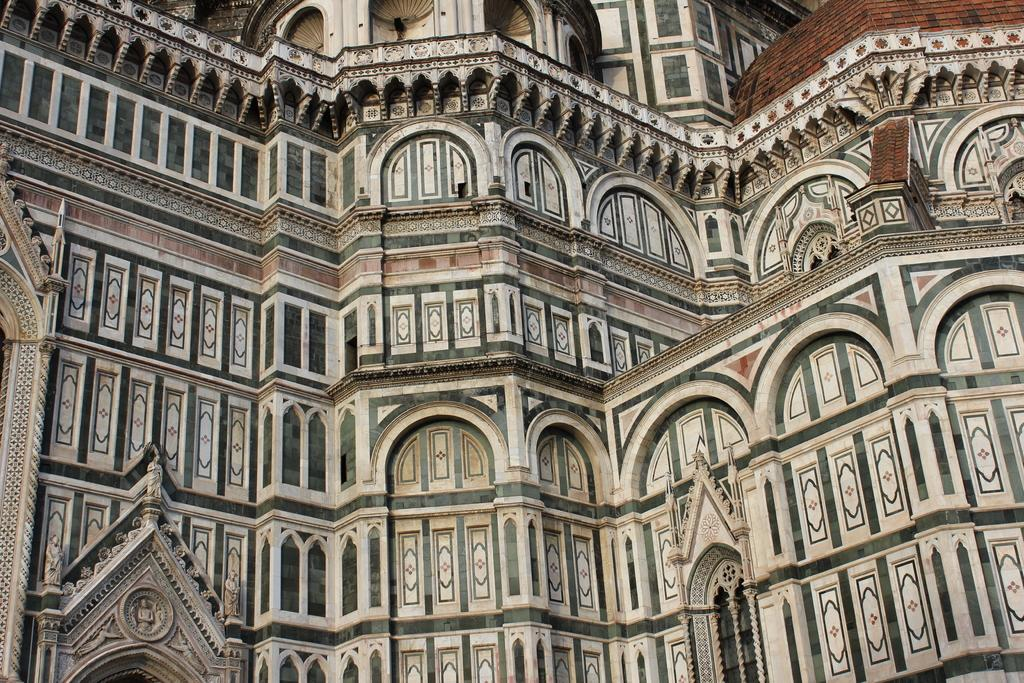What is the main subject of the image? There is a building in the center of the image. Can you describe the building in the image? Unfortunately, the provided facts do not give any details about the building's appearance or features. Is there anything else visible in the image besides the building? The provided facts do not mention any other objects or subjects in the image. What type of music is being played in the building in the image? There is no information about music or any sounds in the image, as it only features a building in the center. 